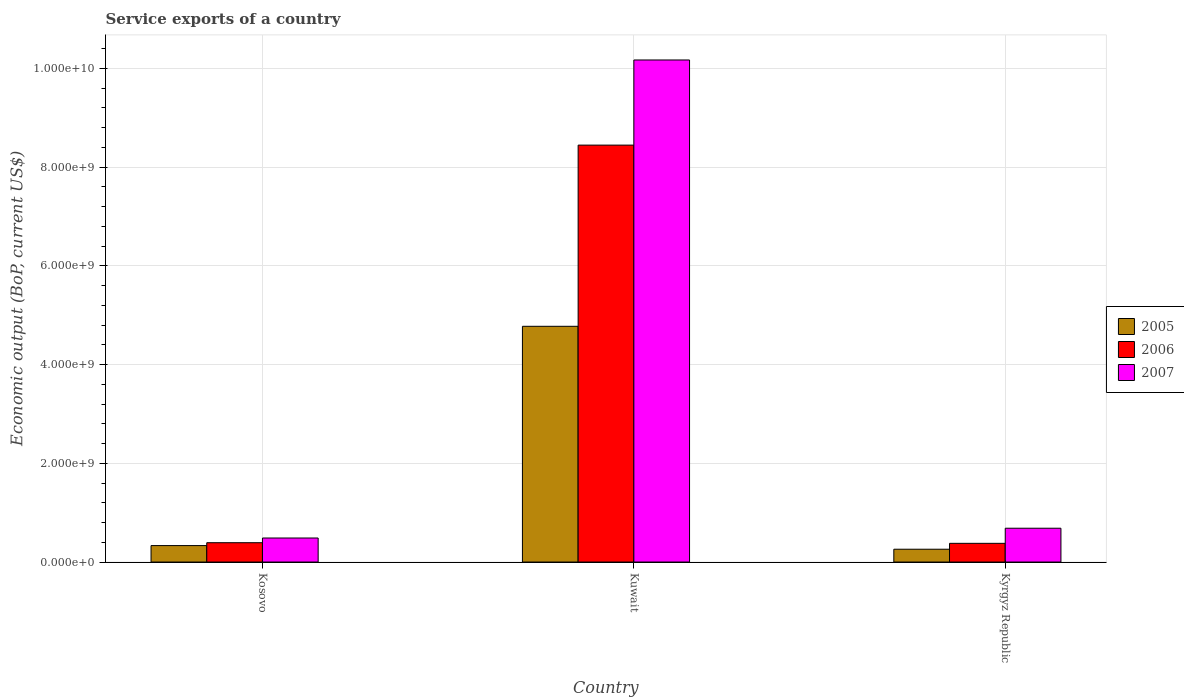How many different coloured bars are there?
Provide a short and direct response. 3. Are the number of bars per tick equal to the number of legend labels?
Give a very brief answer. Yes. How many bars are there on the 3rd tick from the right?
Provide a short and direct response. 3. What is the label of the 1st group of bars from the left?
Provide a succinct answer. Kosovo. In how many cases, is the number of bars for a given country not equal to the number of legend labels?
Your response must be concise. 0. What is the service exports in 2006 in Kyrgyz Republic?
Keep it short and to the point. 3.79e+08. Across all countries, what is the maximum service exports in 2005?
Make the answer very short. 4.77e+09. Across all countries, what is the minimum service exports in 2005?
Your answer should be compact. 2.59e+08. In which country was the service exports in 2007 maximum?
Make the answer very short. Kuwait. In which country was the service exports in 2005 minimum?
Your answer should be very brief. Kyrgyz Republic. What is the total service exports in 2006 in the graph?
Provide a succinct answer. 9.21e+09. What is the difference between the service exports in 2006 in Kosovo and that in Kuwait?
Your answer should be compact. -8.05e+09. What is the difference between the service exports in 2006 in Kyrgyz Republic and the service exports in 2007 in Kuwait?
Your response must be concise. -9.79e+09. What is the average service exports in 2007 per country?
Provide a succinct answer. 3.78e+09. What is the difference between the service exports of/in 2007 and service exports of/in 2005 in Kyrgyz Republic?
Offer a very short reply. 4.25e+08. What is the ratio of the service exports in 2007 in Kosovo to that in Kyrgyz Republic?
Offer a very short reply. 0.71. Is the difference between the service exports in 2007 in Kosovo and Kuwait greater than the difference between the service exports in 2005 in Kosovo and Kuwait?
Your answer should be compact. No. What is the difference between the highest and the second highest service exports in 2006?
Your response must be concise. -8.05e+09. What is the difference between the highest and the lowest service exports in 2007?
Your answer should be compact. 9.68e+09. How many bars are there?
Offer a terse response. 9. What is the difference between two consecutive major ticks on the Y-axis?
Your answer should be very brief. 2.00e+09. Does the graph contain any zero values?
Offer a terse response. No. Does the graph contain grids?
Your response must be concise. Yes. How many legend labels are there?
Offer a very short reply. 3. What is the title of the graph?
Offer a very short reply. Service exports of a country. What is the label or title of the Y-axis?
Make the answer very short. Economic output (BoP, current US$). What is the Economic output (BoP, current US$) in 2005 in Kosovo?
Your answer should be compact. 3.33e+08. What is the Economic output (BoP, current US$) in 2006 in Kosovo?
Your answer should be very brief. 3.91e+08. What is the Economic output (BoP, current US$) in 2007 in Kosovo?
Ensure brevity in your answer.  4.86e+08. What is the Economic output (BoP, current US$) of 2005 in Kuwait?
Your answer should be compact. 4.77e+09. What is the Economic output (BoP, current US$) of 2006 in Kuwait?
Provide a succinct answer. 8.44e+09. What is the Economic output (BoP, current US$) in 2007 in Kuwait?
Offer a very short reply. 1.02e+1. What is the Economic output (BoP, current US$) in 2005 in Kyrgyz Republic?
Offer a terse response. 2.59e+08. What is the Economic output (BoP, current US$) of 2006 in Kyrgyz Republic?
Your response must be concise. 3.79e+08. What is the Economic output (BoP, current US$) of 2007 in Kyrgyz Republic?
Your response must be concise. 6.85e+08. Across all countries, what is the maximum Economic output (BoP, current US$) of 2005?
Your answer should be compact. 4.77e+09. Across all countries, what is the maximum Economic output (BoP, current US$) of 2006?
Provide a succinct answer. 8.44e+09. Across all countries, what is the maximum Economic output (BoP, current US$) in 2007?
Offer a terse response. 1.02e+1. Across all countries, what is the minimum Economic output (BoP, current US$) in 2005?
Keep it short and to the point. 2.59e+08. Across all countries, what is the minimum Economic output (BoP, current US$) in 2006?
Ensure brevity in your answer.  3.79e+08. Across all countries, what is the minimum Economic output (BoP, current US$) in 2007?
Your answer should be compact. 4.86e+08. What is the total Economic output (BoP, current US$) of 2005 in the graph?
Your answer should be very brief. 5.37e+09. What is the total Economic output (BoP, current US$) of 2006 in the graph?
Keep it short and to the point. 9.21e+09. What is the total Economic output (BoP, current US$) in 2007 in the graph?
Keep it short and to the point. 1.13e+1. What is the difference between the Economic output (BoP, current US$) in 2005 in Kosovo and that in Kuwait?
Your answer should be compact. -4.44e+09. What is the difference between the Economic output (BoP, current US$) of 2006 in Kosovo and that in Kuwait?
Keep it short and to the point. -8.05e+09. What is the difference between the Economic output (BoP, current US$) in 2007 in Kosovo and that in Kuwait?
Your response must be concise. -9.68e+09. What is the difference between the Economic output (BoP, current US$) in 2005 in Kosovo and that in Kyrgyz Republic?
Provide a short and direct response. 7.38e+07. What is the difference between the Economic output (BoP, current US$) of 2006 in Kosovo and that in Kyrgyz Republic?
Provide a succinct answer. 1.25e+07. What is the difference between the Economic output (BoP, current US$) of 2007 in Kosovo and that in Kyrgyz Republic?
Keep it short and to the point. -1.98e+08. What is the difference between the Economic output (BoP, current US$) of 2005 in Kuwait and that in Kyrgyz Republic?
Offer a terse response. 4.52e+09. What is the difference between the Economic output (BoP, current US$) in 2006 in Kuwait and that in Kyrgyz Republic?
Make the answer very short. 8.07e+09. What is the difference between the Economic output (BoP, current US$) in 2007 in Kuwait and that in Kyrgyz Republic?
Your answer should be compact. 9.48e+09. What is the difference between the Economic output (BoP, current US$) in 2005 in Kosovo and the Economic output (BoP, current US$) in 2006 in Kuwait?
Provide a short and direct response. -8.11e+09. What is the difference between the Economic output (BoP, current US$) of 2005 in Kosovo and the Economic output (BoP, current US$) of 2007 in Kuwait?
Provide a short and direct response. -9.84e+09. What is the difference between the Economic output (BoP, current US$) in 2006 in Kosovo and the Economic output (BoP, current US$) in 2007 in Kuwait?
Ensure brevity in your answer.  -9.78e+09. What is the difference between the Economic output (BoP, current US$) of 2005 in Kosovo and the Economic output (BoP, current US$) of 2006 in Kyrgyz Republic?
Your answer should be compact. -4.55e+07. What is the difference between the Economic output (BoP, current US$) in 2005 in Kosovo and the Economic output (BoP, current US$) in 2007 in Kyrgyz Republic?
Ensure brevity in your answer.  -3.52e+08. What is the difference between the Economic output (BoP, current US$) of 2006 in Kosovo and the Economic output (BoP, current US$) of 2007 in Kyrgyz Republic?
Offer a terse response. -2.94e+08. What is the difference between the Economic output (BoP, current US$) of 2005 in Kuwait and the Economic output (BoP, current US$) of 2006 in Kyrgyz Republic?
Provide a short and direct response. 4.40e+09. What is the difference between the Economic output (BoP, current US$) in 2005 in Kuwait and the Economic output (BoP, current US$) in 2007 in Kyrgyz Republic?
Offer a terse response. 4.09e+09. What is the difference between the Economic output (BoP, current US$) in 2006 in Kuwait and the Economic output (BoP, current US$) in 2007 in Kyrgyz Republic?
Ensure brevity in your answer.  7.76e+09. What is the average Economic output (BoP, current US$) of 2005 per country?
Provide a short and direct response. 1.79e+09. What is the average Economic output (BoP, current US$) of 2006 per country?
Your response must be concise. 3.07e+09. What is the average Economic output (BoP, current US$) in 2007 per country?
Offer a very short reply. 3.78e+09. What is the difference between the Economic output (BoP, current US$) of 2005 and Economic output (BoP, current US$) of 2006 in Kosovo?
Your answer should be very brief. -5.80e+07. What is the difference between the Economic output (BoP, current US$) of 2005 and Economic output (BoP, current US$) of 2007 in Kosovo?
Keep it short and to the point. -1.53e+08. What is the difference between the Economic output (BoP, current US$) in 2006 and Economic output (BoP, current US$) in 2007 in Kosovo?
Your answer should be compact. -9.52e+07. What is the difference between the Economic output (BoP, current US$) in 2005 and Economic output (BoP, current US$) in 2006 in Kuwait?
Provide a short and direct response. -3.67e+09. What is the difference between the Economic output (BoP, current US$) of 2005 and Economic output (BoP, current US$) of 2007 in Kuwait?
Your answer should be compact. -5.39e+09. What is the difference between the Economic output (BoP, current US$) of 2006 and Economic output (BoP, current US$) of 2007 in Kuwait?
Provide a short and direct response. -1.72e+09. What is the difference between the Economic output (BoP, current US$) in 2005 and Economic output (BoP, current US$) in 2006 in Kyrgyz Republic?
Give a very brief answer. -1.19e+08. What is the difference between the Economic output (BoP, current US$) of 2005 and Economic output (BoP, current US$) of 2007 in Kyrgyz Republic?
Keep it short and to the point. -4.25e+08. What is the difference between the Economic output (BoP, current US$) of 2006 and Economic output (BoP, current US$) of 2007 in Kyrgyz Republic?
Keep it short and to the point. -3.06e+08. What is the ratio of the Economic output (BoP, current US$) of 2005 in Kosovo to that in Kuwait?
Offer a terse response. 0.07. What is the ratio of the Economic output (BoP, current US$) in 2006 in Kosovo to that in Kuwait?
Keep it short and to the point. 0.05. What is the ratio of the Economic output (BoP, current US$) in 2007 in Kosovo to that in Kuwait?
Give a very brief answer. 0.05. What is the ratio of the Economic output (BoP, current US$) in 2005 in Kosovo to that in Kyrgyz Republic?
Ensure brevity in your answer.  1.28. What is the ratio of the Economic output (BoP, current US$) in 2006 in Kosovo to that in Kyrgyz Republic?
Keep it short and to the point. 1.03. What is the ratio of the Economic output (BoP, current US$) of 2007 in Kosovo to that in Kyrgyz Republic?
Give a very brief answer. 0.71. What is the ratio of the Economic output (BoP, current US$) in 2005 in Kuwait to that in Kyrgyz Republic?
Provide a short and direct response. 18.41. What is the ratio of the Economic output (BoP, current US$) in 2006 in Kuwait to that in Kyrgyz Republic?
Give a very brief answer. 22.3. What is the ratio of the Economic output (BoP, current US$) in 2007 in Kuwait to that in Kyrgyz Republic?
Your response must be concise. 14.85. What is the difference between the highest and the second highest Economic output (BoP, current US$) of 2005?
Make the answer very short. 4.44e+09. What is the difference between the highest and the second highest Economic output (BoP, current US$) of 2006?
Your answer should be compact. 8.05e+09. What is the difference between the highest and the second highest Economic output (BoP, current US$) in 2007?
Offer a terse response. 9.48e+09. What is the difference between the highest and the lowest Economic output (BoP, current US$) of 2005?
Your response must be concise. 4.52e+09. What is the difference between the highest and the lowest Economic output (BoP, current US$) in 2006?
Offer a very short reply. 8.07e+09. What is the difference between the highest and the lowest Economic output (BoP, current US$) in 2007?
Provide a succinct answer. 9.68e+09. 